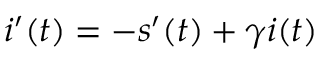Convert formula to latex. <formula><loc_0><loc_0><loc_500><loc_500>i ^ { \prime } ( t ) = - s ^ { \prime } ( t ) + \gamma i ( t )</formula> 